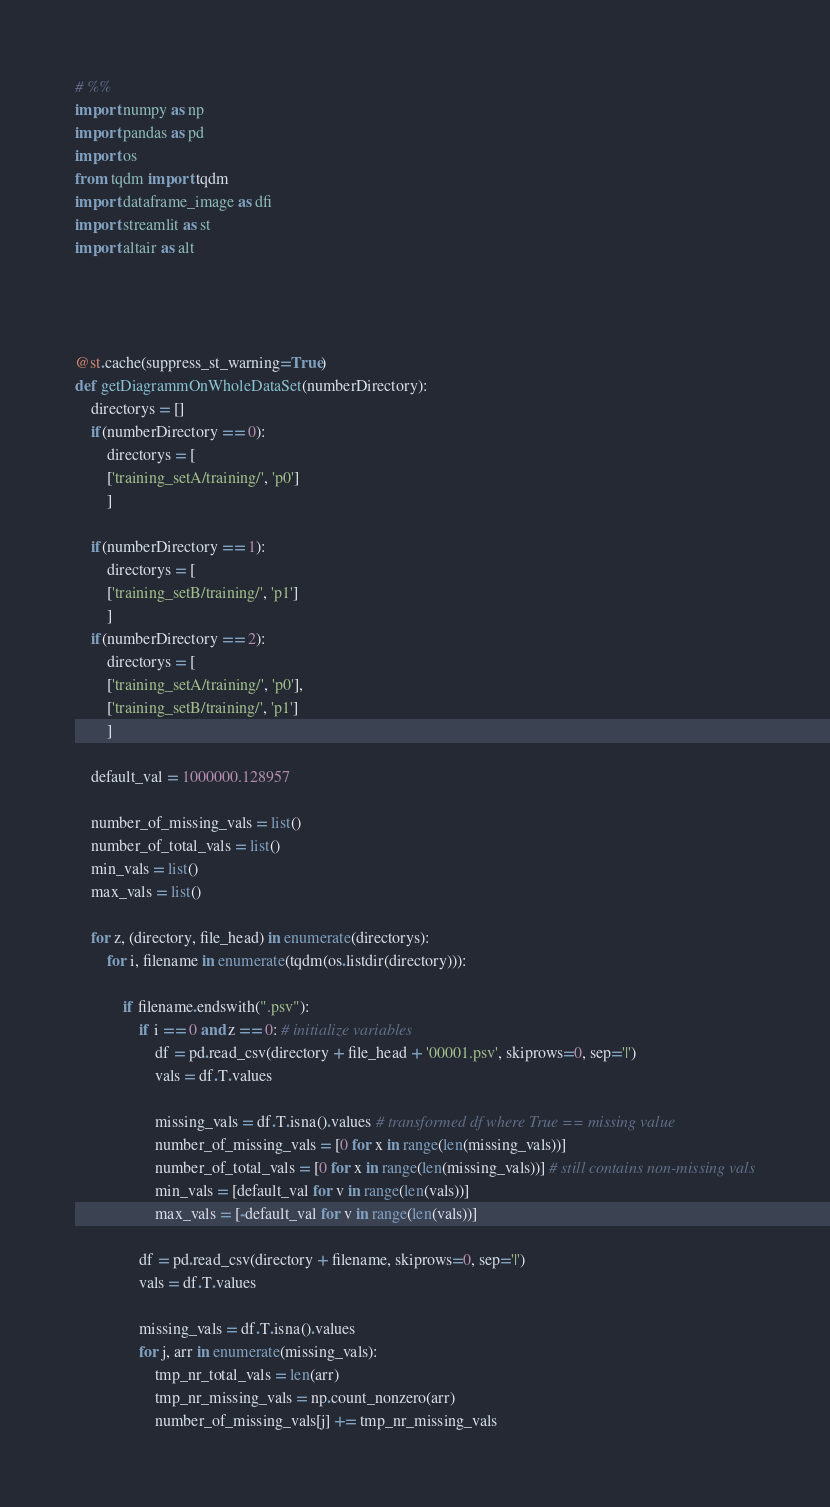Convert code to text. <code><loc_0><loc_0><loc_500><loc_500><_Python_># %%
import numpy as np
import pandas as pd
import os
from tqdm import tqdm
import dataframe_image as dfi
import streamlit as st
import altair as alt




@st.cache(suppress_st_warning=True)
def getDiagrammOnWholeDataSet(numberDirectory):
    directorys = []
    if(numberDirectory == 0):
        directorys = [
        ['training_setA/training/', 'p0']
        ]

    if(numberDirectory == 1):
        directorys = [
        ['training_setB/training/', 'p1']
        ]
    if(numberDirectory == 2):
        directorys = [
        ['training_setA/training/', 'p0'],
        ['training_setB/training/', 'p1']
        ]

    default_val = 1000000.128957

    number_of_missing_vals = list()
    number_of_total_vals = list()
    min_vals = list()
    max_vals = list()

    for z, (directory, file_head) in enumerate(directorys):
        for i, filename in enumerate(tqdm(os.listdir(directory))):

            if filename.endswith(".psv"): 
                if i == 0 and z == 0: # initialize variables
                    df = pd.read_csv(directory + file_head + '00001.psv', skiprows=0, sep='|')
                    vals = df.T.values

                    missing_vals = df.T.isna().values # transformed df where True == missing value
                    number_of_missing_vals = [0 for x in range(len(missing_vals))]
                    number_of_total_vals = [0 for x in range(len(missing_vals))] # still contains non-missing vals
                    min_vals = [default_val for v in range(len(vals))] 
                    max_vals = [-default_val for v in range(len(vals))]

                df = pd.read_csv(directory + filename, skiprows=0, sep='|')
                vals = df.T.values

                missing_vals = df.T.isna().values
                for j, arr in enumerate(missing_vals):
                    tmp_nr_total_vals = len(arr)
                    tmp_nr_missing_vals = np.count_nonzero(arr)
                    number_of_missing_vals[j] += tmp_nr_missing_vals</code> 